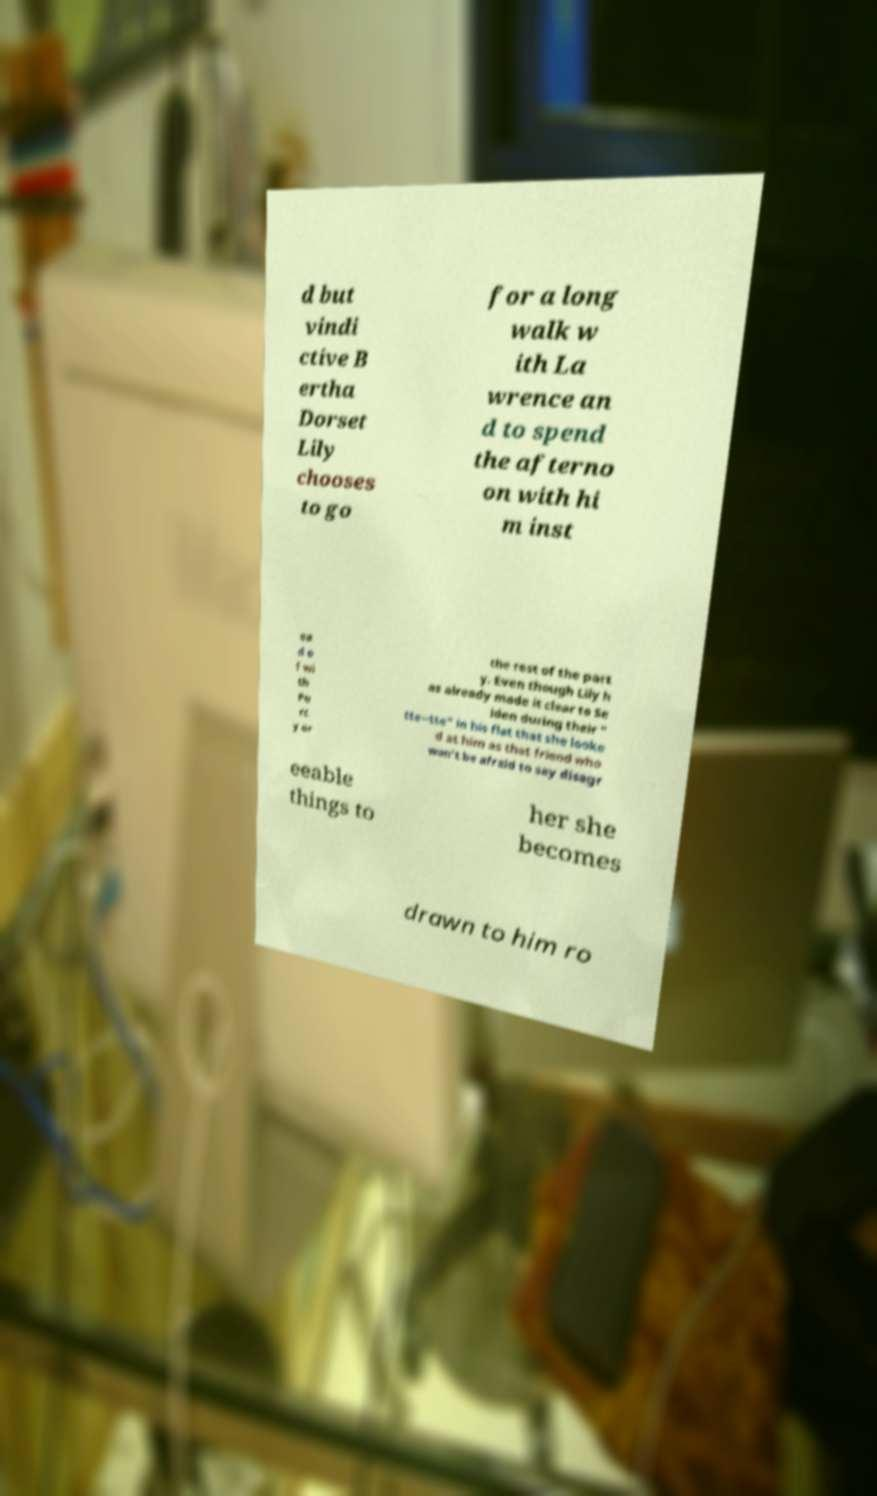Can you read and provide the text displayed in the image?This photo seems to have some interesting text. Can you extract and type it out for me? d but vindi ctive B ertha Dorset Lily chooses to go for a long walk w ith La wrence an d to spend the afterno on with hi m inst ea d o f wi th Pe rc y or the rest of the part y. Even though Lily h as already made it clear to Se lden during their " tte--tte" in his flat that she looke d at him as that friend who won't be afraid to say disagr eeable things to her she becomes drawn to him ro 